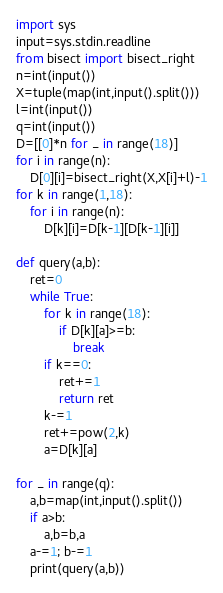Convert code to text. <code><loc_0><loc_0><loc_500><loc_500><_Python_>import sys
input=sys.stdin.readline
from bisect import bisect_right
n=int(input())
X=tuple(map(int,input().split()))
l=int(input())
q=int(input())
D=[[0]*n for _ in range(18)]
for i in range(n):
    D[0][i]=bisect_right(X,X[i]+l)-1
for k in range(1,18):
    for i in range(n):
        D[k][i]=D[k-1][D[k-1][i]]

def query(a,b):
    ret=0
    while True:
        for k in range(18):
            if D[k][a]>=b:
                break
        if k==0:
            ret+=1
            return ret
        k-=1
        ret+=pow(2,k)
        a=D[k][a]

for _ in range(q):
    a,b=map(int,input().split())
    if a>b:
        a,b=b,a
    a-=1; b-=1
    print(query(a,b))</code> 